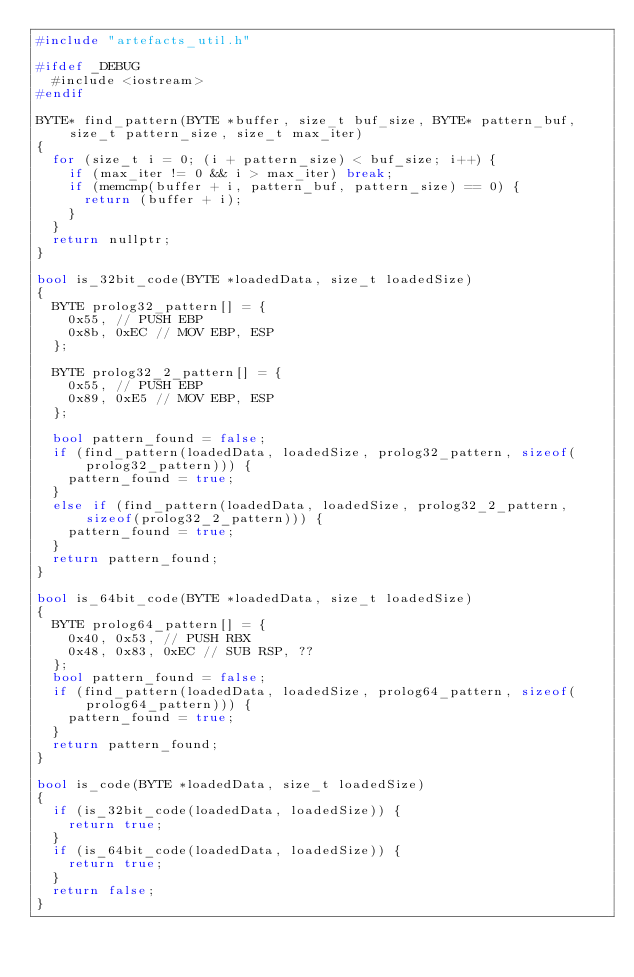<code> <loc_0><loc_0><loc_500><loc_500><_C++_>#include "artefacts_util.h"

#ifdef _DEBUG
	#include <iostream>
#endif

BYTE* find_pattern(BYTE *buffer, size_t buf_size, BYTE* pattern_buf, size_t pattern_size, size_t max_iter)
{
	for (size_t i = 0; (i + pattern_size) < buf_size; i++) {
		if (max_iter != 0 && i > max_iter) break;
		if (memcmp(buffer + i, pattern_buf, pattern_size) == 0) {
			return (buffer + i);
		}
	}
	return nullptr;
}

bool is_32bit_code(BYTE *loadedData, size_t loadedSize)
{
	BYTE prolog32_pattern[] = {
		0x55, // PUSH EBP
		0x8b, 0xEC // MOV EBP, ESP
	};

	BYTE prolog32_2_pattern[] = {
		0x55, // PUSH EBP
		0x89, 0xE5 // MOV EBP, ESP
	};

	bool pattern_found = false;
	if (find_pattern(loadedData, loadedSize, prolog32_pattern, sizeof(prolog32_pattern))) {
		pattern_found = true;
	}
	else if (find_pattern(loadedData, loadedSize, prolog32_2_pattern, sizeof(prolog32_2_pattern))) {
		pattern_found = true;
	}
	return pattern_found;
}

bool is_64bit_code(BYTE *loadedData, size_t loadedSize)
{
	BYTE prolog64_pattern[] = {
		0x40, 0x53, // PUSH RBX
		0x48, 0x83, 0xEC // SUB RSP, ??
	};
	bool pattern_found = false;
	if (find_pattern(loadedData, loadedSize, prolog64_pattern, sizeof(prolog64_pattern))) {
		pattern_found = true;
	}
	return pattern_found;
}

bool is_code(BYTE *loadedData, size_t loadedSize)
{
	if (is_32bit_code(loadedData, loadedSize)) {
		return true;
	}
	if (is_64bit_code(loadedData, loadedSize)) {
		return true;
	}
	return false;
}
</code> 